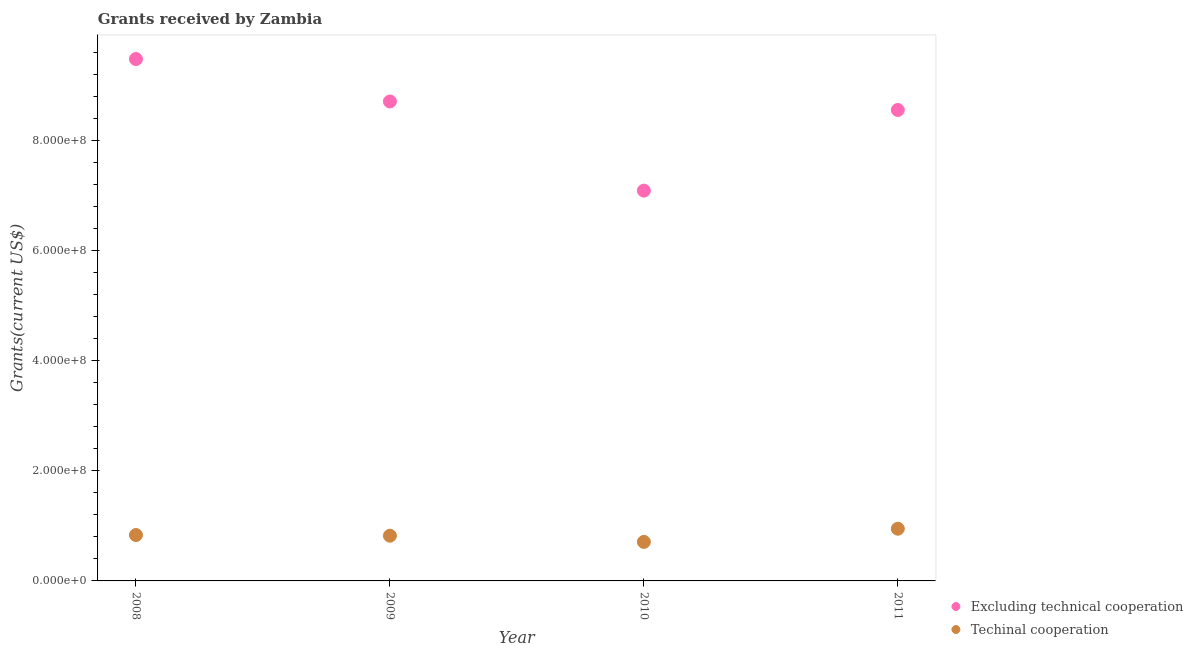Is the number of dotlines equal to the number of legend labels?
Keep it short and to the point. Yes. What is the amount of grants received(excluding technical cooperation) in 2009?
Keep it short and to the point. 8.71e+08. Across all years, what is the maximum amount of grants received(including technical cooperation)?
Your answer should be compact. 9.49e+07. Across all years, what is the minimum amount of grants received(including technical cooperation)?
Provide a short and direct response. 7.09e+07. In which year was the amount of grants received(excluding technical cooperation) maximum?
Ensure brevity in your answer.  2008. In which year was the amount of grants received(excluding technical cooperation) minimum?
Offer a terse response. 2010. What is the total amount of grants received(excluding technical cooperation) in the graph?
Make the answer very short. 3.39e+09. What is the difference between the amount of grants received(including technical cooperation) in 2009 and that in 2011?
Your answer should be compact. -1.27e+07. What is the difference between the amount of grants received(excluding technical cooperation) in 2010 and the amount of grants received(including technical cooperation) in 2009?
Ensure brevity in your answer.  6.27e+08. What is the average amount of grants received(excluding technical cooperation) per year?
Make the answer very short. 8.46e+08. In the year 2010, what is the difference between the amount of grants received(including technical cooperation) and amount of grants received(excluding technical cooperation)?
Make the answer very short. -6.38e+08. In how many years, is the amount of grants received(excluding technical cooperation) greater than 280000000 US$?
Your response must be concise. 4. What is the ratio of the amount of grants received(excluding technical cooperation) in 2009 to that in 2011?
Give a very brief answer. 1.02. Is the amount of grants received(excluding technical cooperation) in 2008 less than that in 2011?
Offer a terse response. No. Is the difference between the amount of grants received(including technical cooperation) in 2008 and 2011 greater than the difference between the amount of grants received(excluding technical cooperation) in 2008 and 2011?
Provide a succinct answer. No. What is the difference between the highest and the second highest amount of grants received(including technical cooperation)?
Offer a terse response. 1.15e+07. What is the difference between the highest and the lowest amount of grants received(including technical cooperation)?
Your answer should be very brief. 2.40e+07. Is the sum of the amount of grants received(excluding technical cooperation) in 2009 and 2010 greater than the maximum amount of grants received(including technical cooperation) across all years?
Offer a terse response. Yes. Does the amount of grants received(excluding technical cooperation) monotonically increase over the years?
Your answer should be compact. No. How many dotlines are there?
Your answer should be very brief. 2. How many years are there in the graph?
Your response must be concise. 4. What is the difference between two consecutive major ticks on the Y-axis?
Provide a short and direct response. 2.00e+08. Are the values on the major ticks of Y-axis written in scientific E-notation?
Provide a succinct answer. Yes. Where does the legend appear in the graph?
Give a very brief answer. Bottom right. How many legend labels are there?
Give a very brief answer. 2. What is the title of the graph?
Offer a very short reply. Grants received by Zambia. What is the label or title of the X-axis?
Provide a succinct answer. Year. What is the label or title of the Y-axis?
Make the answer very short. Grants(current US$). What is the Grants(current US$) of Excluding technical cooperation in 2008?
Make the answer very short. 9.49e+08. What is the Grants(current US$) in Techinal cooperation in 2008?
Give a very brief answer. 8.34e+07. What is the Grants(current US$) of Excluding technical cooperation in 2009?
Your response must be concise. 8.71e+08. What is the Grants(current US$) of Techinal cooperation in 2009?
Make the answer very short. 8.22e+07. What is the Grants(current US$) of Excluding technical cooperation in 2010?
Your response must be concise. 7.09e+08. What is the Grants(current US$) in Techinal cooperation in 2010?
Give a very brief answer. 7.09e+07. What is the Grants(current US$) of Excluding technical cooperation in 2011?
Keep it short and to the point. 8.56e+08. What is the Grants(current US$) of Techinal cooperation in 2011?
Give a very brief answer. 9.49e+07. Across all years, what is the maximum Grants(current US$) of Excluding technical cooperation?
Give a very brief answer. 9.49e+08. Across all years, what is the maximum Grants(current US$) of Techinal cooperation?
Give a very brief answer. 9.49e+07. Across all years, what is the minimum Grants(current US$) in Excluding technical cooperation?
Your answer should be very brief. 7.09e+08. Across all years, what is the minimum Grants(current US$) in Techinal cooperation?
Ensure brevity in your answer.  7.09e+07. What is the total Grants(current US$) in Excluding technical cooperation in the graph?
Make the answer very short. 3.39e+09. What is the total Grants(current US$) of Techinal cooperation in the graph?
Your answer should be compact. 3.31e+08. What is the difference between the Grants(current US$) of Excluding technical cooperation in 2008 and that in 2009?
Offer a terse response. 7.72e+07. What is the difference between the Grants(current US$) of Techinal cooperation in 2008 and that in 2009?
Make the answer very short. 1.23e+06. What is the difference between the Grants(current US$) of Excluding technical cooperation in 2008 and that in 2010?
Ensure brevity in your answer.  2.39e+08. What is the difference between the Grants(current US$) of Techinal cooperation in 2008 and that in 2010?
Keep it short and to the point. 1.25e+07. What is the difference between the Grants(current US$) of Excluding technical cooperation in 2008 and that in 2011?
Offer a very short reply. 9.26e+07. What is the difference between the Grants(current US$) in Techinal cooperation in 2008 and that in 2011?
Keep it short and to the point. -1.15e+07. What is the difference between the Grants(current US$) of Excluding technical cooperation in 2009 and that in 2010?
Provide a succinct answer. 1.62e+08. What is the difference between the Grants(current US$) in Techinal cooperation in 2009 and that in 2010?
Keep it short and to the point. 1.12e+07. What is the difference between the Grants(current US$) in Excluding technical cooperation in 2009 and that in 2011?
Your response must be concise. 1.54e+07. What is the difference between the Grants(current US$) in Techinal cooperation in 2009 and that in 2011?
Your answer should be very brief. -1.27e+07. What is the difference between the Grants(current US$) of Excluding technical cooperation in 2010 and that in 2011?
Make the answer very short. -1.47e+08. What is the difference between the Grants(current US$) in Techinal cooperation in 2010 and that in 2011?
Provide a short and direct response. -2.40e+07. What is the difference between the Grants(current US$) in Excluding technical cooperation in 2008 and the Grants(current US$) in Techinal cooperation in 2009?
Make the answer very short. 8.66e+08. What is the difference between the Grants(current US$) in Excluding technical cooperation in 2008 and the Grants(current US$) in Techinal cooperation in 2010?
Provide a short and direct response. 8.78e+08. What is the difference between the Grants(current US$) in Excluding technical cooperation in 2008 and the Grants(current US$) in Techinal cooperation in 2011?
Provide a succinct answer. 8.54e+08. What is the difference between the Grants(current US$) in Excluding technical cooperation in 2009 and the Grants(current US$) in Techinal cooperation in 2010?
Offer a very short reply. 8.01e+08. What is the difference between the Grants(current US$) in Excluding technical cooperation in 2009 and the Grants(current US$) in Techinal cooperation in 2011?
Offer a terse response. 7.77e+08. What is the difference between the Grants(current US$) in Excluding technical cooperation in 2010 and the Grants(current US$) in Techinal cooperation in 2011?
Your answer should be very brief. 6.14e+08. What is the average Grants(current US$) of Excluding technical cooperation per year?
Your answer should be very brief. 8.46e+08. What is the average Grants(current US$) of Techinal cooperation per year?
Offer a very short reply. 8.28e+07. In the year 2008, what is the difference between the Grants(current US$) in Excluding technical cooperation and Grants(current US$) in Techinal cooperation?
Your answer should be very brief. 8.65e+08. In the year 2009, what is the difference between the Grants(current US$) of Excluding technical cooperation and Grants(current US$) of Techinal cooperation?
Provide a succinct answer. 7.89e+08. In the year 2010, what is the difference between the Grants(current US$) of Excluding technical cooperation and Grants(current US$) of Techinal cooperation?
Keep it short and to the point. 6.38e+08. In the year 2011, what is the difference between the Grants(current US$) in Excluding technical cooperation and Grants(current US$) in Techinal cooperation?
Offer a terse response. 7.61e+08. What is the ratio of the Grants(current US$) in Excluding technical cooperation in 2008 to that in 2009?
Offer a very short reply. 1.09. What is the ratio of the Grants(current US$) in Techinal cooperation in 2008 to that in 2009?
Give a very brief answer. 1.01. What is the ratio of the Grants(current US$) in Excluding technical cooperation in 2008 to that in 2010?
Offer a terse response. 1.34. What is the ratio of the Grants(current US$) of Techinal cooperation in 2008 to that in 2010?
Your answer should be very brief. 1.18. What is the ratio of the Grants(current US$) in Excluding technical cooperation in 2008 to that in 2011?
Provide a succinct answer. 1.11. What is the ratio of the Grants(current US$) of Techinal cooperation in 2008 to that in 2011?
Provide a succinct answer. 0.88. What is the ratio of the Grants(current US$) in Excluding technical cooperation in 2009 to that in 2010?
Offer a very short reply. 1.23. What is the ratio of the Grants(current US$) of Techinal cooperation in 2009 to that in 2010?
Give a very brief answer. 1.16. What is the ratio of the Grants(current US$) of Techinal cooperation in 2009 to that in 2011?
Keep it short and to the point. 0.87. What is the ratio of the Grants(current US$) in Excluding technical cooperation in 2010 to that in 2011?
Make the answer very short. 0.83. What is the ratio of the Grants(current US$) in Techinal cooperation in 2010 to that in 2011?
Give a very brief answer. 0.75. What is the difference between the highest and the second highest Grants(current US$) of Excluding technical cooperation?
Provide a succinct answer. 7.72e+07. What is the difference between the highest and the second highest Grants(current US$) in Techinal cooperation?
Give a very brief answer. 1.15e+07. What is the difference between the highest and the lowest Grants(current US$) of Excluding technical cooperation?
Your answer should be compact. 2.39e+08. What is the difference between the highest and the lowest Grants(current US$) in Techinal cooperation?
Provide a succinct answer. 2.40e+07. 